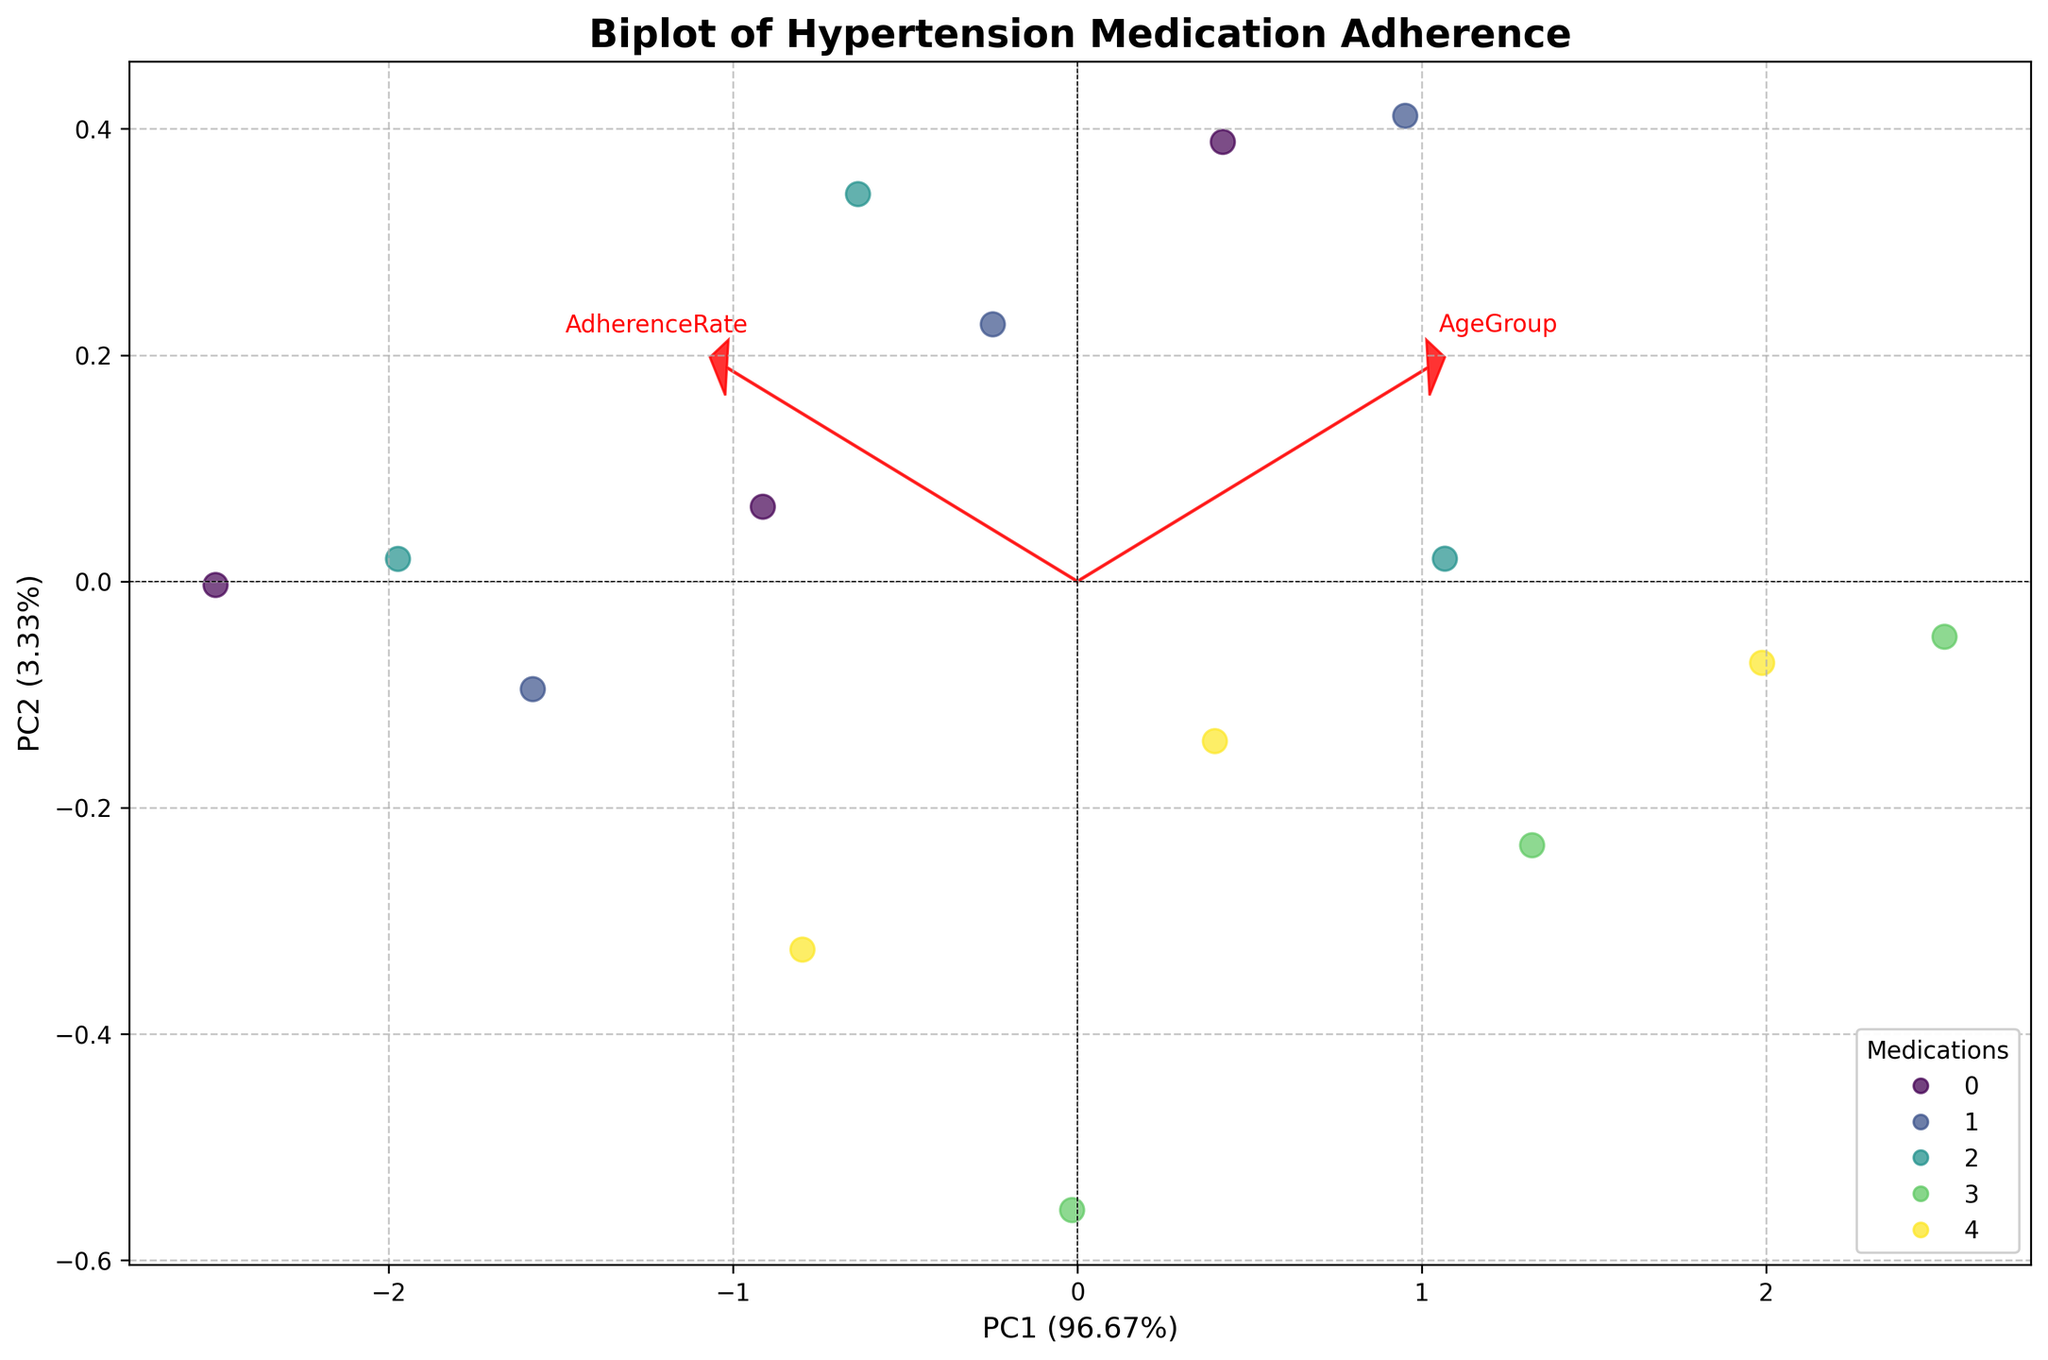What is the title of the plot? The title is displayed at the top of the figure and usually provides a summary of what the visualization represents. Here, the title is "Biplot of Hypertension Medication Adherence".
Answer: Biplot of Hypertension Medication Adherence What are the two metrics represented by the loadings? The loadings in a biplot typically represent the original variables being transformed. The red arrows and the corresponding labels for the loadings here are "AdherenceRate" and "SideEffectScore".
Answer: AdherenceRate and SideEffectScore Which medication shows the highest adherence rate in the 55+ age group? This can be assessed by looking at the scatter points and identifying which one has a high PC1 score (since it's related to adherence rate) and refers to the 55+ age group which clusters around that area. The Extended-Release Metoprolol shows the highest adherence rate in this age group.
Answer: Metoprolol (Extended-Release) Which axis has the higher variance explained by its principal component? By examining the labels on the axes, we see the percentage of variance explained. PC1's variance explanation is higher (with a percentage closer to 50%) than PC2.
Answer: PC1 Are adherence rate and side effect score positively or negatively correlated in this biplot? By observing the direction of the loadings (arrows), if both arrows point towards the same direction, it indicates a positive correlation. Here, they point towards different directions, suggesting a negative correlation.
Answer: Negatively correlated Which two medications have the lowest adherence rates for the 18-34 age group? By identifying points representing the medications that cluster with lower PC1 scores within the 18-34 age group, Amlodipine and Losartan show the lowest adherence rates.
Answer: Amlodipine and Losartan Is there a noticeable trend in adherence rate with increasing age groups for any medication? Identifying the patterns and movements of clustered points (18-34, 35-54, 55+) along the PCs can show trends. For Metoprolol (Extended-Release), adherence rates noticeably increase with age.
Answer: Yes, for Metoprolol (Extended-Release) Which formulation type appears to have the best adherence rate across all age groups? By looking at the clusters referring to different formulation types and their positions on PC1, the Extended-Release Metoprolol consistently appears at higher PC1 scores across age groups compared to others.
Answer: Extended-Release Metoprolol How well do the two principal components explain the total variation in the dataset? Summing the variance explained percentages of PC1 and PC2 as indicated on the axis labels (which typically add up to around 1), gives the total variance explained. If PC1 explains around ~50% and PC2 ~30%, the total variance explained is 80%.
Answer: Approximately 80% 